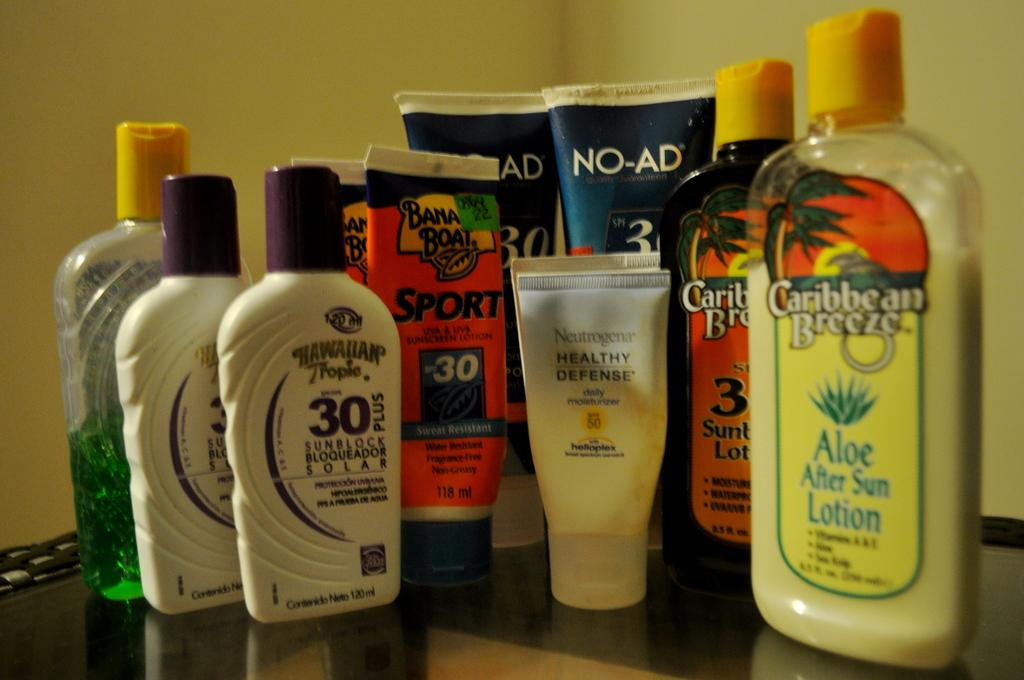<image>
Share a concise interpretation of the image provided. A selection of sunbathing products including Banana Boat brand. 